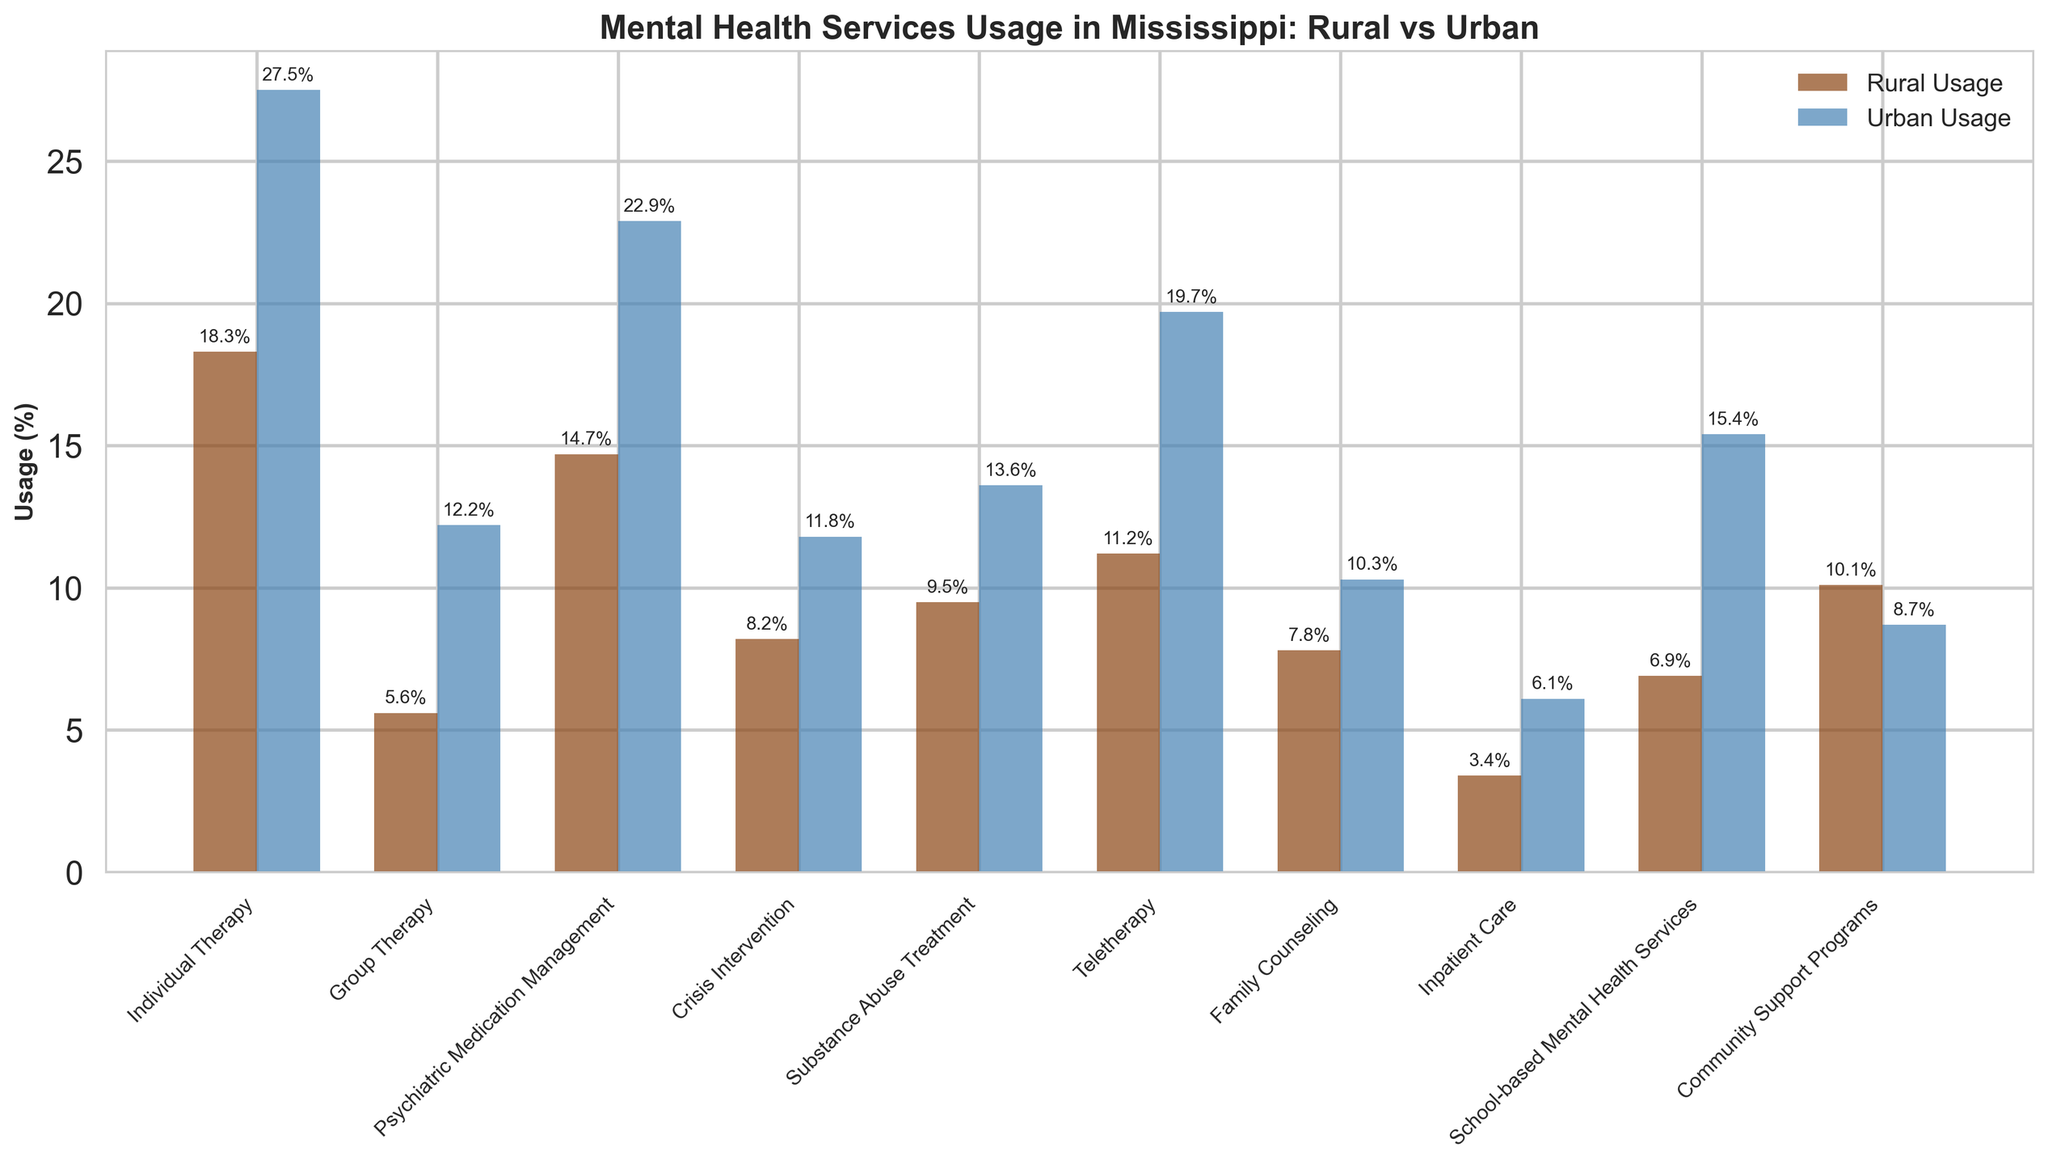What is the difference in usage rates of Individual Therapy between rural and urban areas? To find the difference, subtract the rural usage rate from the urban usage rate for Individual Therapy. Urban usage (27.5%) - Rural usage (18.3%) = 9.2%.
Answer: 9.2% Which type of mental health service has the highest usage rate in urban areas? Compare the urban usage rates for all service types. Individual Therapy has the highest usage rate at 27.5%.
Answer: Individual Therapy How much higher is the usage rate of School-based Mental Health Services in urban areas compared to rural areas? Subtract the rural School-based Mental Health Services usage rate from the urban rate. Urban (15.4%) - Rural (6.9%) = 8.5%.
Answer: 8.5% What is the average rural usage rate for Crisis Intervention, Teletherapy, and Family Counseling? Sum the usage rates of the three services in rural areas and divide by three: (8.2% + 11.2% + 7.8%) / 3 = 9.07%.
Answer: 9.07% Which type of mental health service has a higher usage rate in rural areas compared to urban areas, and by how much? Only Community Support Programs have a higher rural usage rate than urban. Subtract urban usage rate from rural usage rate: Rural (10.1%) - Urban (8.7%) = 1.4%.
Answer: Community Support Programs by 1.4% Between Substance Abuse Treatment and Teletherapy, which service has a greater difference in usage rates between rural and urban areas? Calculate the differences: Substance Abuse Treatment (13.6% - 9.5% = 4.1%) and Teletherapy (19.7% - 11.2% = 8.5%). Teletherapy has a greater difference.
Answer: Teletherapy What is the combined urban usage rate for Group Therapy and Inpatient Care? Add the urban usage rates for Group Therapy and Inpatient Care: 12.2% + 6.1% = 18.3%.
Answer: 18.3% 